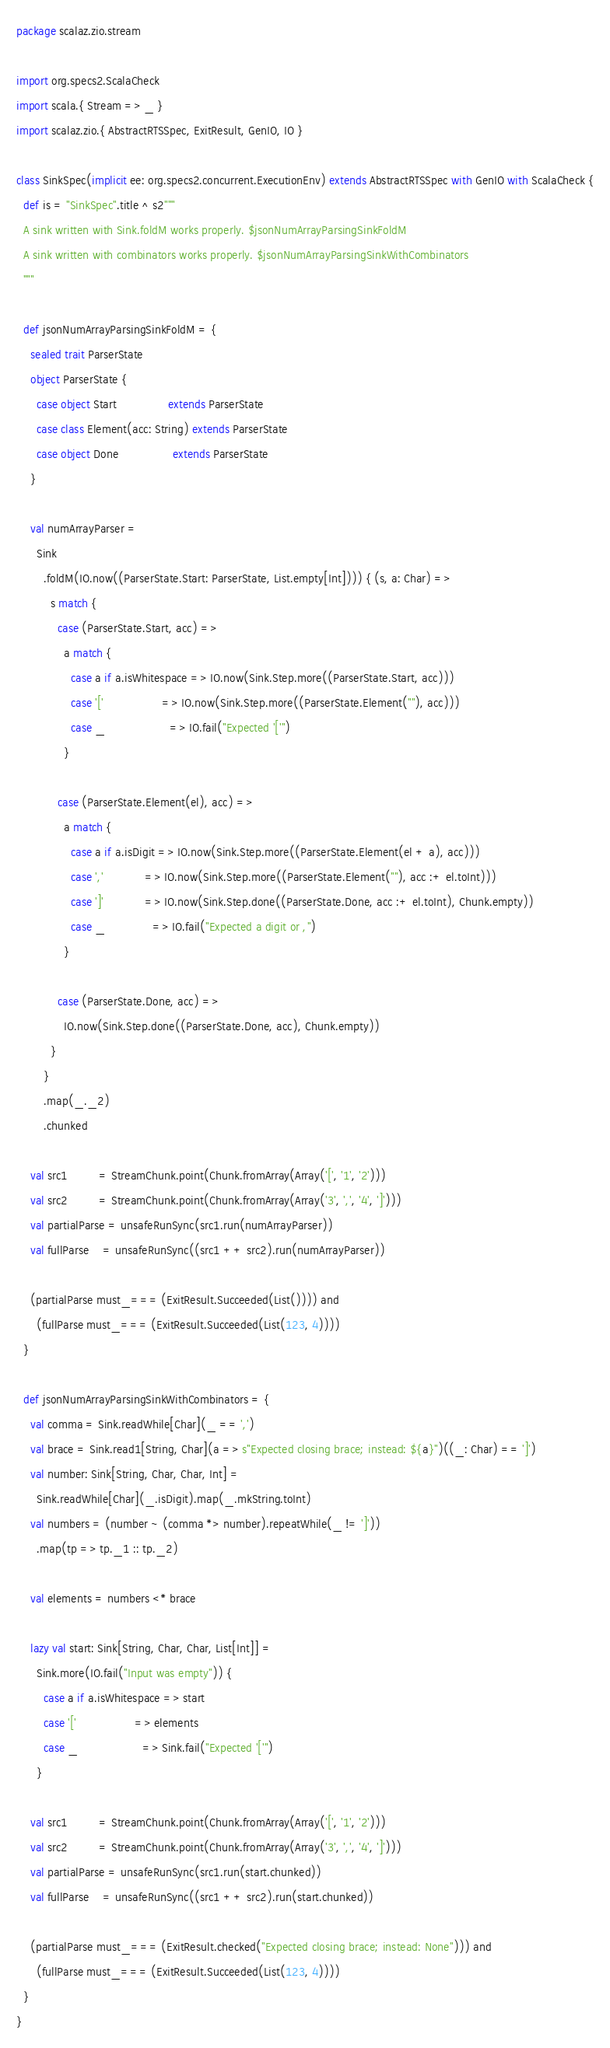Convert code to text. <code><loc_0><loc_0><loc_500><loc_500><_Scala_>package scalaz.zio.stream

import org.specs2.ScalaCheck
import scala.{ Stream => _ }
import scalaz.zio.{ AbstractRTSSpec, ExitResult, GenIO, IO }

class SinkSpec(implicit ee: org.specs2.concurrent.ExecutionEnv) extends AbstractRTSSpec with GenIO with ScalaCheck {
  def is = "SinkSpec".title ^ s2"""
  A sink written with Sink.foldM works properly. $jsonNumArrayParsingSinkFoldM
  A sink written with combinators works properly. $jsonNumArrayParsingSinkWithCombinators
  """

  def jsonNumArrayParsingSinkFoldM = {
    sealed trait ParserState
    object ParserState {
      case object Start               extends ParserState
      case class Element(acc: String) extends ParserState
      case object Done                extends ParserState
    }

    val numArrayParser =
      Sink
        .foldM(IO.now((ParserState.Start: ParserState, List.empty[Int]))) { (s, a: Char) =>
          s match {
            case (ParserState.Start, acc) =>
              a match {
                case a if a.isWhitespace => IO.now(Sink.Step.more((ParserState.Start, acc)))
                case '['                 => IO.now(Sink.Step.more((ParserState.Element(""), acc)))
                case _                   => IO.fail("Expected '['")
              }

            case (ParserState.Element(el), acc) =>
              a match {
                case a if a.isDigit => IO.now(Sink.Step.more((ParserState.Element(el + a), acc)))
                case ','            => IO.now(Sink.Step.more((ParserState.Element(""), acc :+ el.toInt)))
                case ']'            => IO.now(Sink.Step.done((ParserState.Done, acc :+ el.toInt), Chunk.empty))
                case _              => IO.fail("Expected a digit or ,")
              }

            case (ParserState.Done, acc) =>
              IO.now(Sink.Step.done((ParserState.Done, acc), Chunk.empty))
          }
        }
        .map(_._2)
        .chunked

    val src1         = StreamChunk.point(Chunk.fromArray(Array('[', '1', '2')))
    val src2         = StreamChunk.point(Chunk.fromArray(Array('3', ',', '4', ']')))
    val partialParse = unsafeRunSync(src1.run(numArrayParser))
    val fullParse    = unsafeRunSync((src1 ++ src2).run(numArrayParser))

    (partialParse must_=== (ExitResult.Succeeded(List()))) and
      (fullParse must_=== (ExitResult.Succeeded(List(123, 4))))
  }

  def jsonNumArrayParsingSinkWithCombinators = {
    val comma = Sink.readWhile[Char](_ == ',')
    val brace = Sink.read1[String, Char](a => s"Expected closing brace; instead: ${a}")((_: Char) == ']')
    val number: Sink[String, Char, Char, Int] =
      Sink.readWhile[Char](_.isDigit).map(_.mkString.toInt)
    val numbers = (number ~ (comma *> number).repeatWhile(_ != ']'))
      .map(tp => tp._1 :: tp._2)

    val elements = numbers <* brace

    lazy val start: Sink[String, Char, Char, List[Int]] =
      Sink.more(IO.fail("Input was empty")) {
        case a if a.isWhitespace => start
        case '['                 => elements
        case _                   => Sink.fail("Expected '['")
      }

    val src1         = StreamChunk.point(Chunk.fromArray(Array('[', '1', '2')))
    val src2         = StreamChunk.point(Chunk.fromArray(Array('3', ',', '4', ']')))
    val partialParse = unsafeRunSync(src1.run(start.chunked))
    val fullParse    = unsafeRunSync((src1 ++ src2).run(start.chunked))

    (partialParse must_=== (ExitResult.checked("Expected closing brace; instead: None"))) and
      (fullParse must_=== (ExitResult.Succeeded(List(123, 4))))
  }
}
</code> 